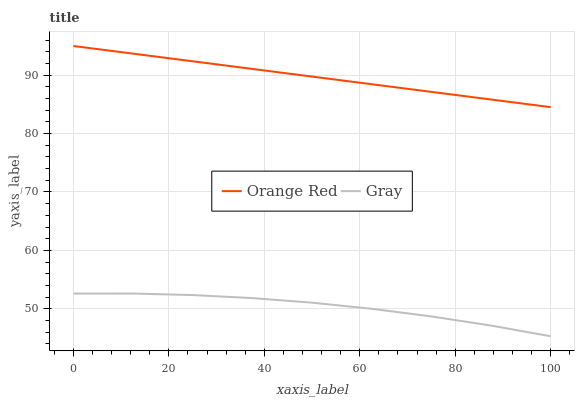Does Orange Red have the minimum area under the curve?
Answer yes or no. No. Is Orange Red the roughest?
Answer yes or no. No. Does Orange Red have the lowest value?
Answer yes or no. No. Is Gray less than Orange Red?
Answer yes or no. Yes. Is Orange Red greater than Gray?
Answer yes or no. Yes. Does Gray intersect Orange Red?
Answer yes or no. No. 